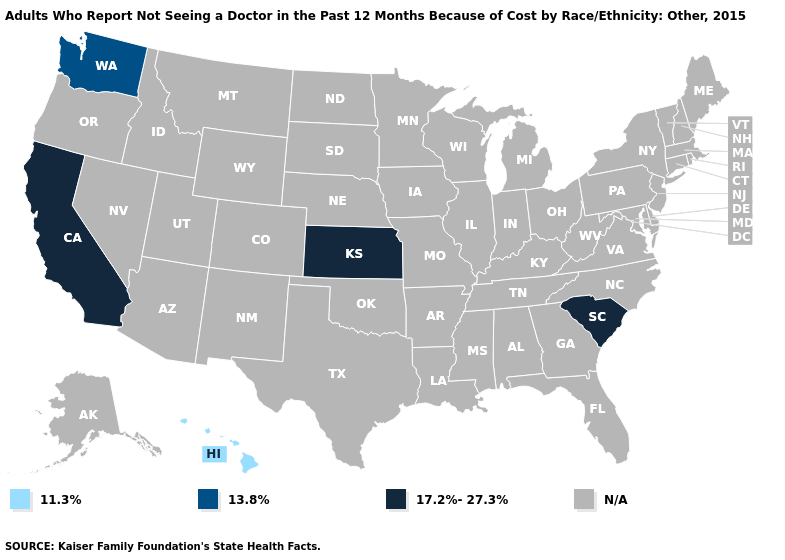Which states have the highest value in the USA?
Answer briefly. California, Kansas, South Carolina. Name the states that have a value in the range 11.3%?
Quick response, please. Hawaii. What is the value of Connecticut?
Be succinct. N/A. What is the value of Louisiana?
Short answer required. N/A. Name the states that have a value in the range 13.8%?
Be succinct. Washington. What is the value of Hawaii?
Write a very short answer. 11.3%. Name the states that have a value in the range 11.3%?
Concise answer only. Hawaii. Name the states that have a value in the range 13.8%?
Concise answer only. Washington. What is the value of Alabama?
Be succinct. N/A. Does the map have missing data?
Give a very brief answer. Yes. What is the value of Nevada?
Quick response, please. N/A. Among the states that border Nebraska , which have the lowest value?
Quick response, please. Kansas. 